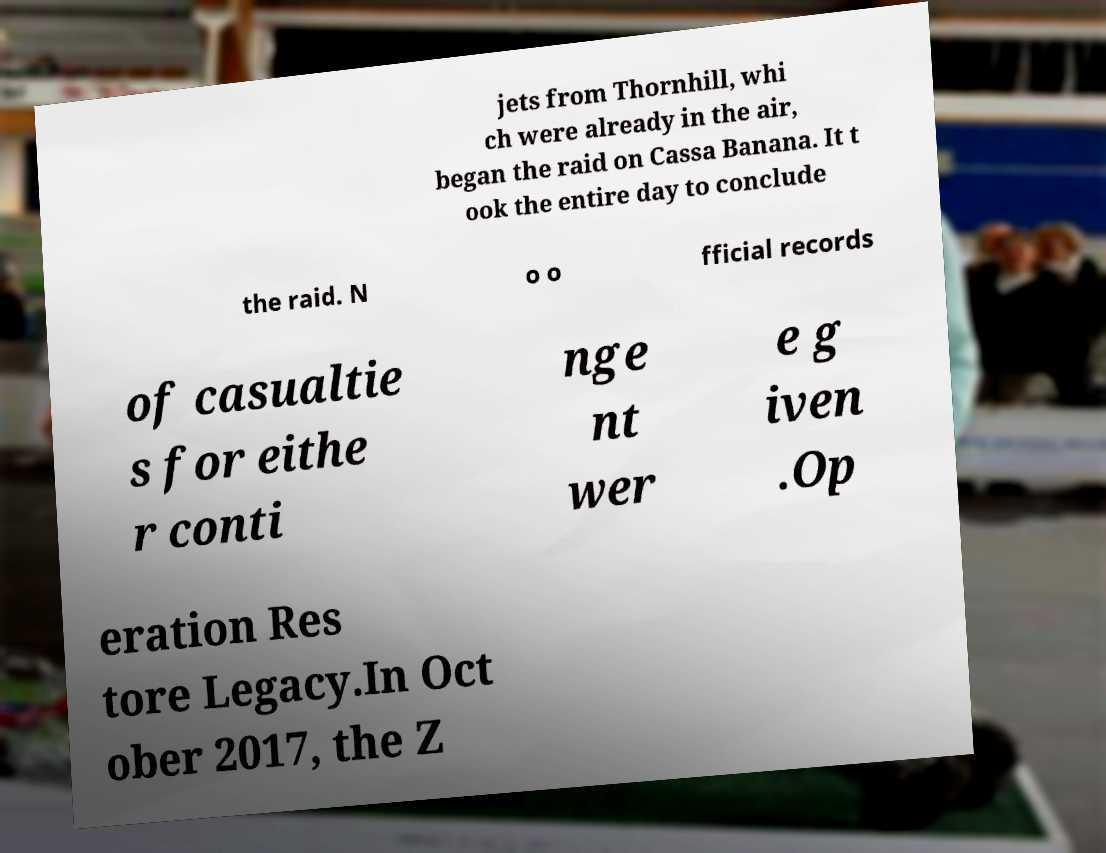I need the written content from this picture converted into text. Can you do that? jets from Thornhill, whi ch were already in the air, began the raid on Cassa Banana. It t ook the entire day to conclude the raid. N o o fficial records of casualtie s for eithe r conti nge nt wer e g iven .Op eration Res tore Legacy.In Oct ober 2017, the Z 